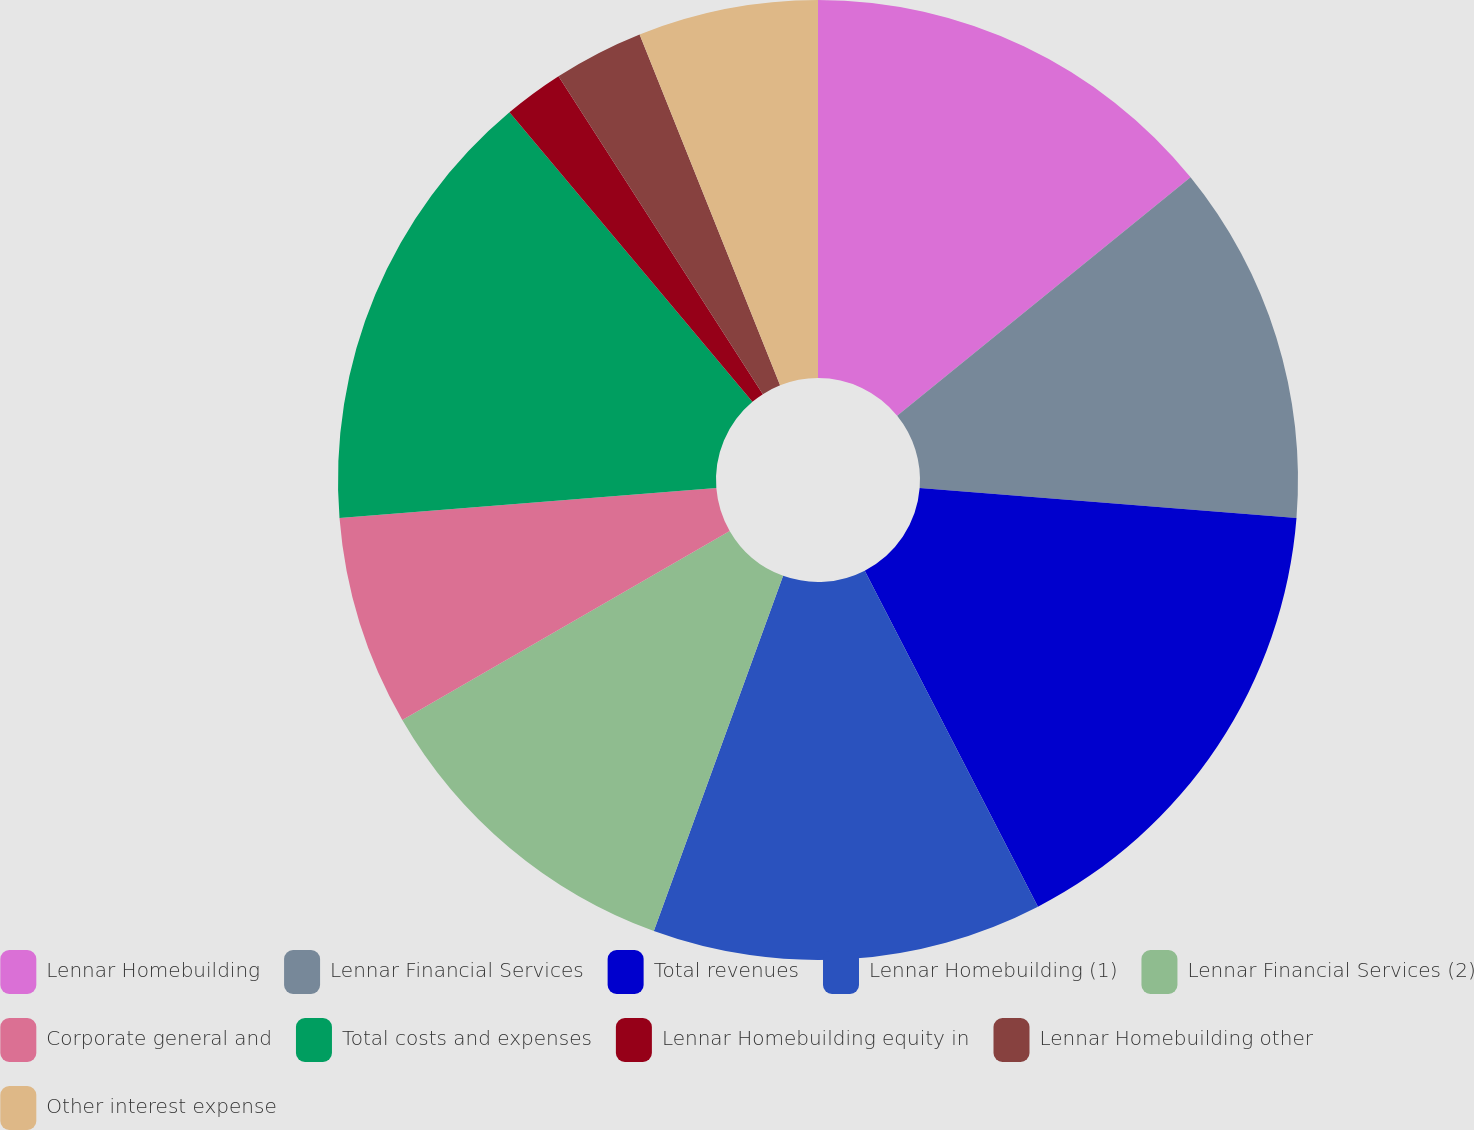Convert chart to OTSL. <chart><loc_0><loc_0><loc_500><loc_500><pie_chart><fcel>Lennar Homebuilding<fcel>Lennar Financial Services<fcel>Total revenues<fcel>Lennar Homebuilding (1)<fcel>Lennar Financial Services (2)<fcel>Corporate general and<fcel>Total costs and expenses<fcel>Lennar Homebuilding equity in<fcel>Lennar Homebuilding other<fcel>Other interest expense<nl><fcel>14.14%<fcel>12.12%<fcel>16.16%<fcel>13.13%<fcel>11.11%<fcel>7.07%<fcel>15.15%<fcel>2.02%<fcel>3.03%<fcel>6.06%<nl></chart> 